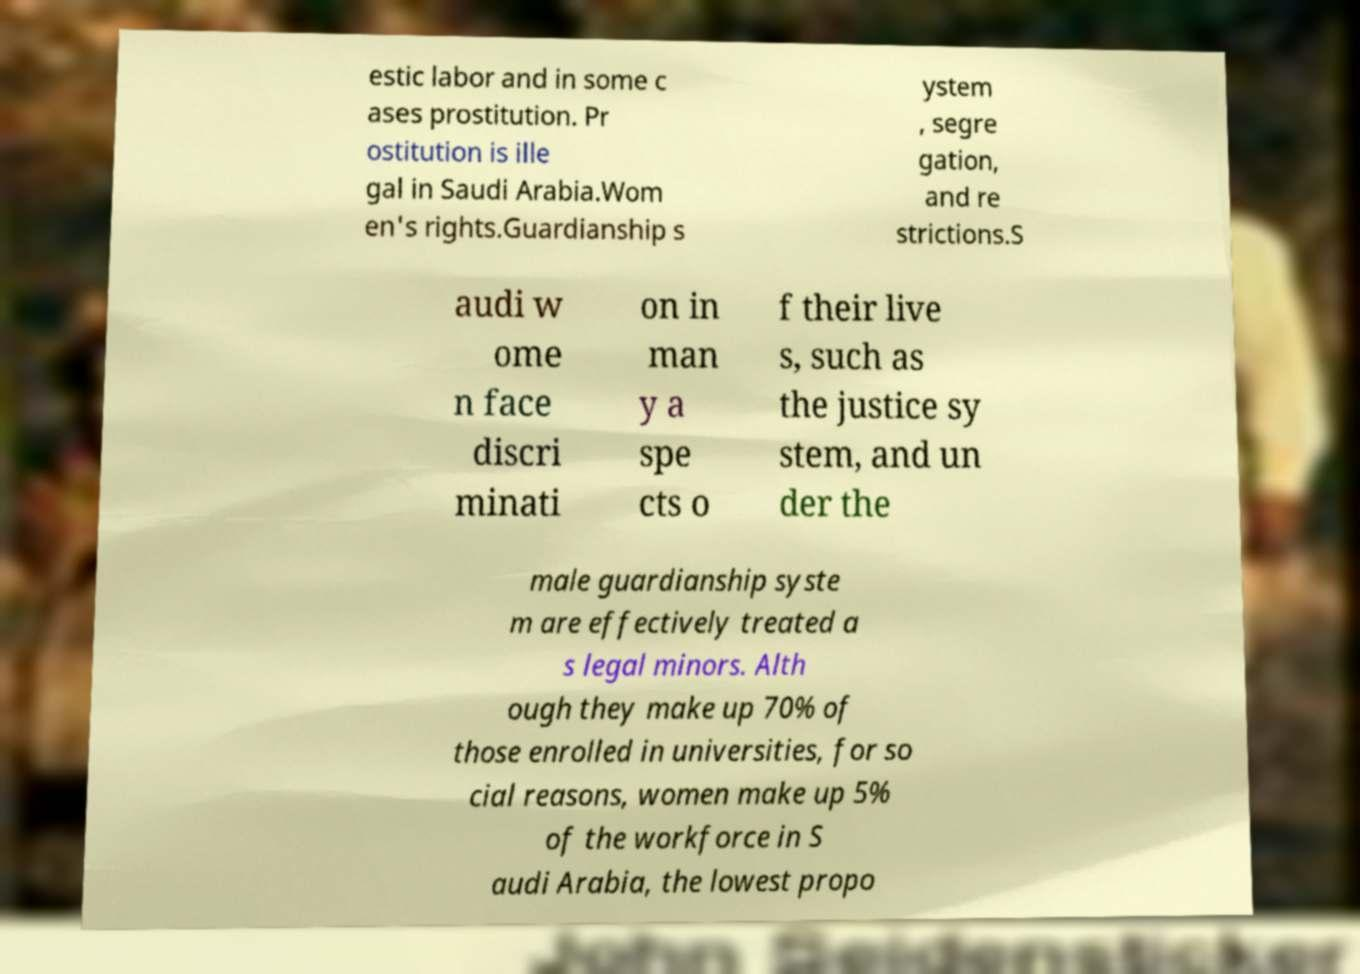Please identify and transcribe the text found in this image. estic labor and in some c ases prostitution. Pr ostitution is ille gal in Saudi Arabia.Wom en's rights.Guardianship s ystem , segre gation, and re strictions.S audi w ome n face discri minati on in man y a spe cts o f their live s, such as the justice sy stem, and un der the male guardianship syste m are effectively treated a s legal minors. Alth ough they make up 70% of those enrolled in universities, for so cial reasons, women make up 5% of the workforce in S audi Arabia, the lowest propo 